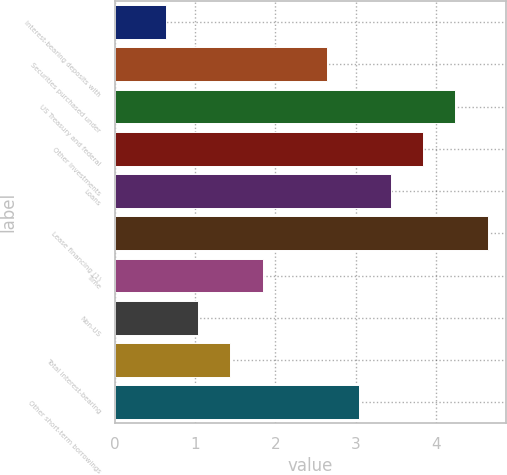<chart> <loc_0><loc_0><loc_500><loc_500><bar_chart><fcel>Interest-bearing deposits with<fcel>Securities purchased under<fcel>US Treasury and federal<fcel>Other investments<fcel>Loans<fcel>Lease financing (1)<fcel>Time<fcel>Non-US<fcel>Total interest-bearing<fcel>Other short-term borrowings<nl><fcel>0.64<fcel>2.64<fcel>4.24<fcel>3.84<fcel>3.44<fcel>4.64<fcel>1.84<fcel>1.04<fcel>1.44<fcel>3.04<nl></chart> 